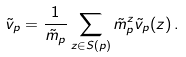Convert formula to latex. <formula><loc_0><loc_0><loc_500><loc_500>\tilde { v } _ { p } = \frac { 1 } { \tilde { m } _ { p } } \sum _ { z \in S ( p ) } \tilde { m } ^ { z } _ { p } \tilde { v } _ { p } ( z ) \, .</formula> 